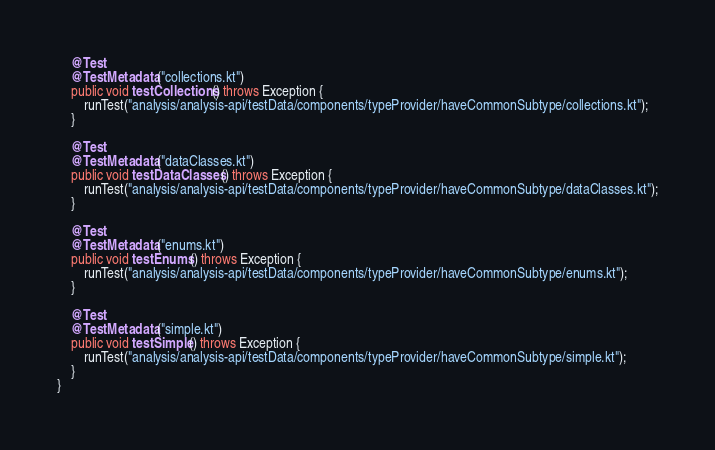<code> <loc_0><loc_0><loc_500><loc_500><_Java_>    @Test
    @TestMetadata("collections.kt")
    public void testCollections() throws Exception {
        runTest("analysis/analysis-api/testData/components/typeProvider/haveCommonSubtype/collections.kt");
    }

    @Test
    @TestMetadata("dataClasses.kt")
    public void testDataClasses() throws Exception {
        runTest("analysis/analysis-api/testData/components/typeProvider/haveCommonSubtype/dataClasses.kt");
    }

    @Test
    @TestMetadata("enums.kt")
    public void testEnums() throws Exception {
        runTest("analysis/analysis-api/testData/components/typeProvider/haveCommonSubtype/enums.kt");
    }

    @Test
    @TestMetadata("simple.kt")
    public void testSimple() throws Exception {
        runTest("analysis/analysis-api/testData/components/typeProvider/haveCommonSubtype/simple.kt");
    }
}
</code> 